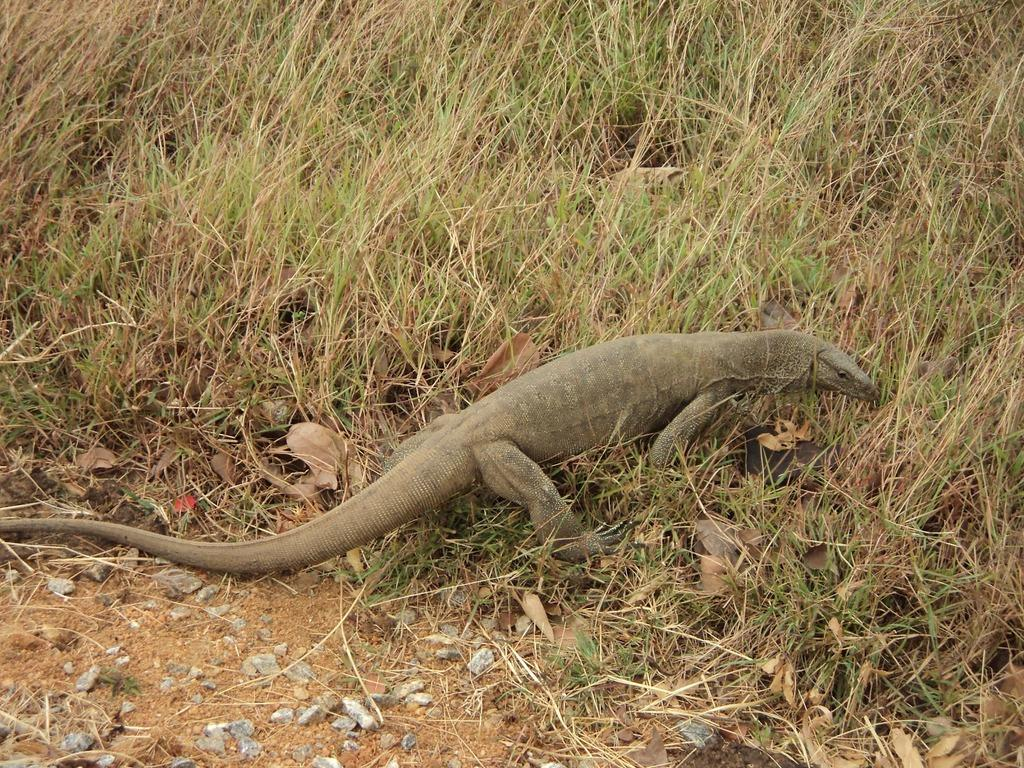What type of animal is in the image? There is a reptile in the image. Where is the reptile located? The reptile is on the grass. What other natural elements can be seen in the image? Dried leaves and stones are visible in the image. What month is it in the image? The month cannot be determined from the image, as it does not contain any information about the time of year. 